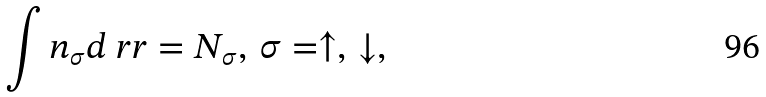<formula> <loc_0><loc_0><loc_500><loc_500>\int n _ { \sigma } d \ r r = N _ { \sigma } , \, \sigma = \uparrow , \, \downarrow ,</formula> 